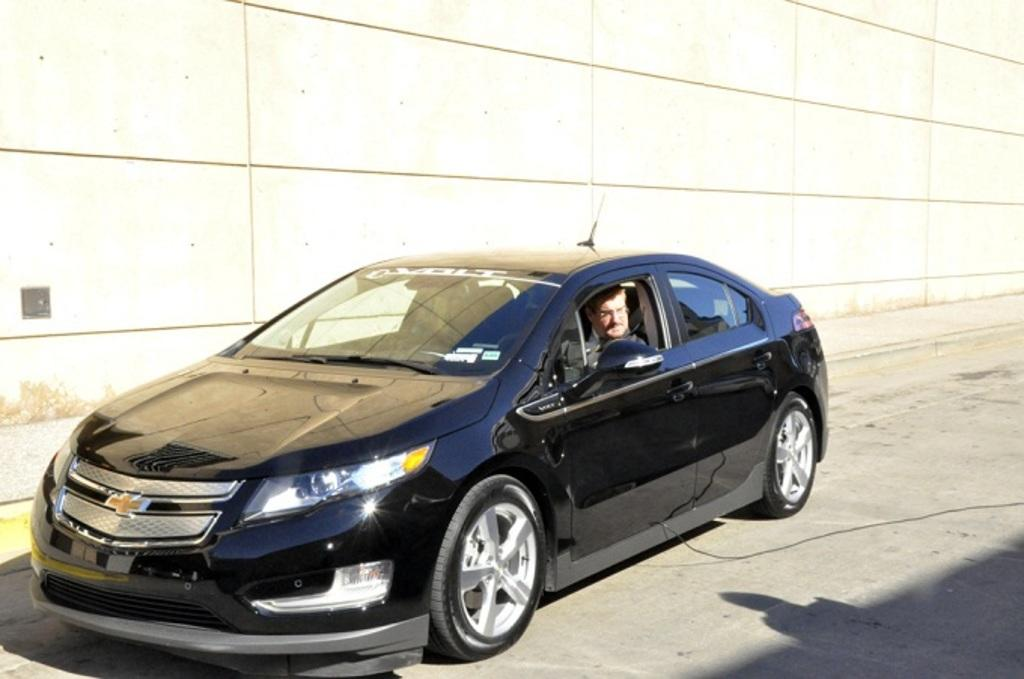What is the main subject in the foreground of the picture? There is a car in the foreground of the picture. Is there anyone inside the car? Yes, there is a person in the car. What can be seen in the background of the picture? There is a construction site in the background of the picture. What is the surface on which the car is located? There is a road at the bottom of the picture. Can you see a crown on the person's head in the car? There is no crown visible on the person's head in the car. Is the person in the car pushing the car? The person in the car is not pushing the car; they are inside the car. 